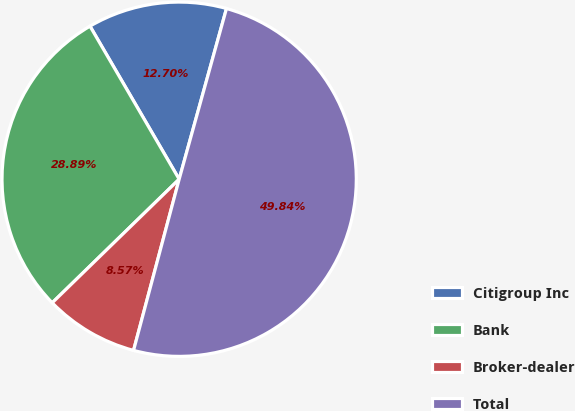Convert chart to OTSL. <chart><loc_0><loc_0><loc_500><loc_500><pie_chart><fcel>Citigroup Inc<fcel>Bank<fcel>Broker-dealer<fcel>Total<nl><fcel>12.7%<fcel>28.89%<fcel>8.57%<fcel>49.84%<nl></chart> 